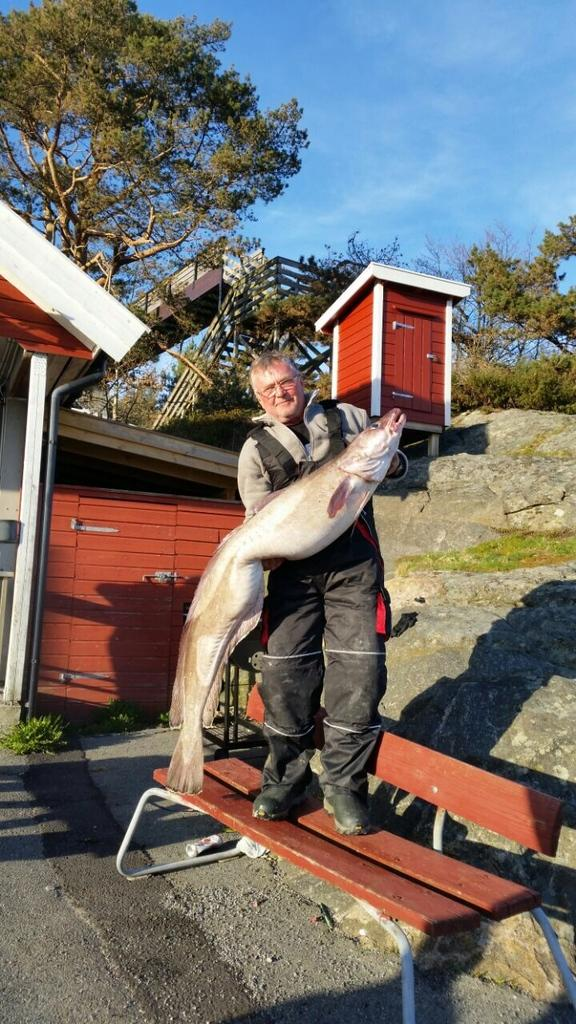What is the man in the image doing while standing on the bench? The man is catching fish in his hand. What other structures can be seen in the image? There is a house and a tree in the image. What is the color of the sky in the image? The sky is visible in the image and is blue in color. Is there any blood visible on the man's hand while he catches the fish in the image? There is no blood visible on the man's hand in the image. What type of cap is the man wearing in the image? The man is not wearing a cap in the image. 